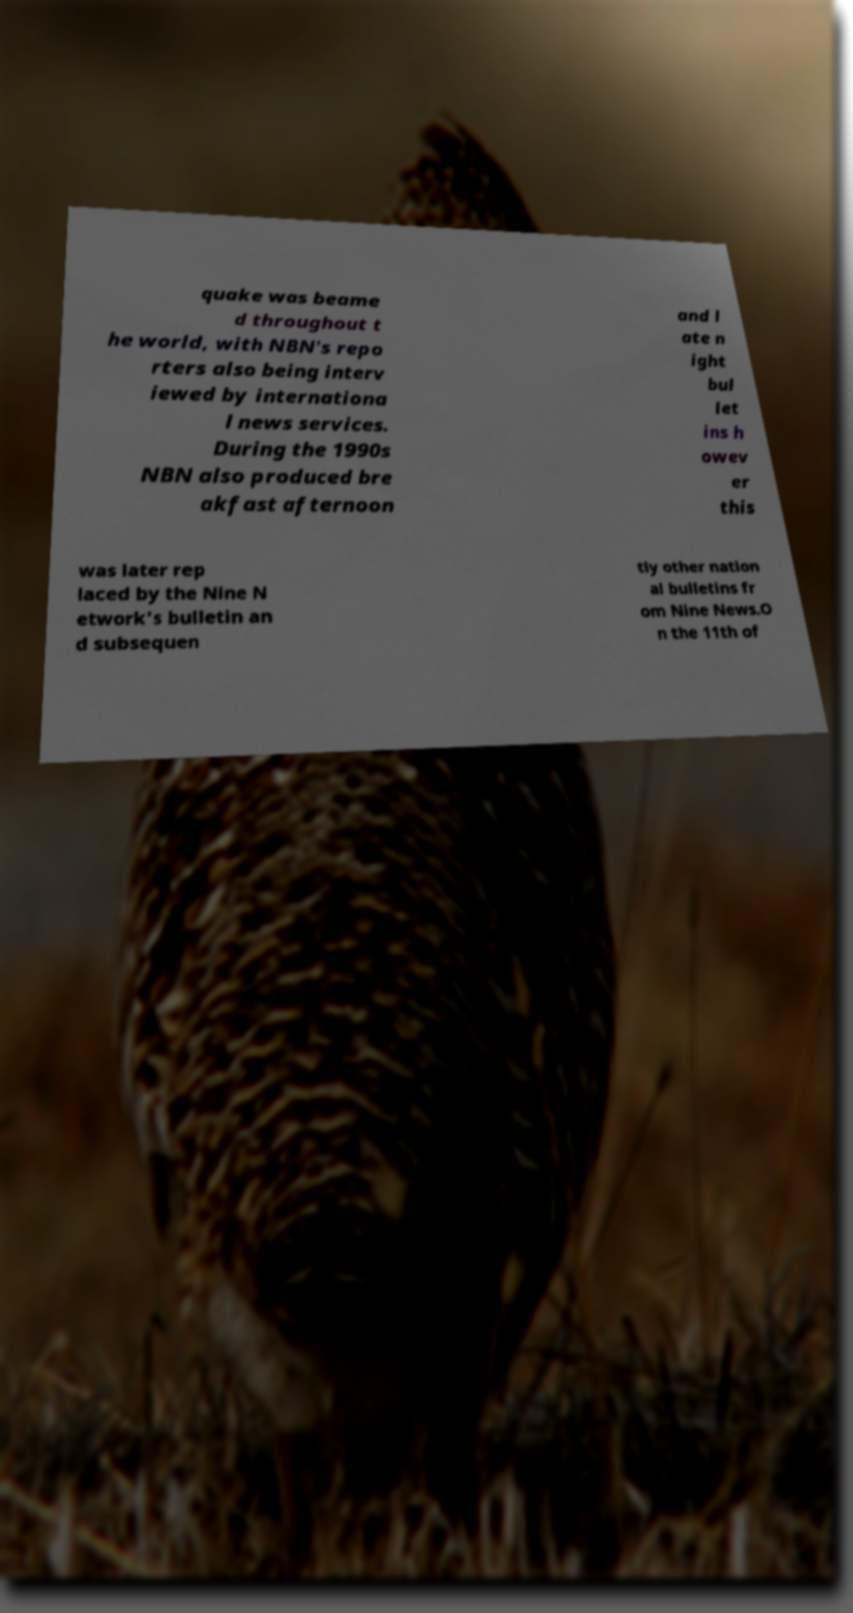Please read and relay the text visible in this image. What does it say? quake was beame d throughout t he world, with NBN's repo rters also being interv iewed by internationa l news services. During the 1990s NBN also produced bre akfast afternoon and l ate n ight bul let ins h owev er this was later rep laced by the Nine N etwork's bulletin an d subsequen tly other nation al bulletins fr om Nine News.O n the 11th of 